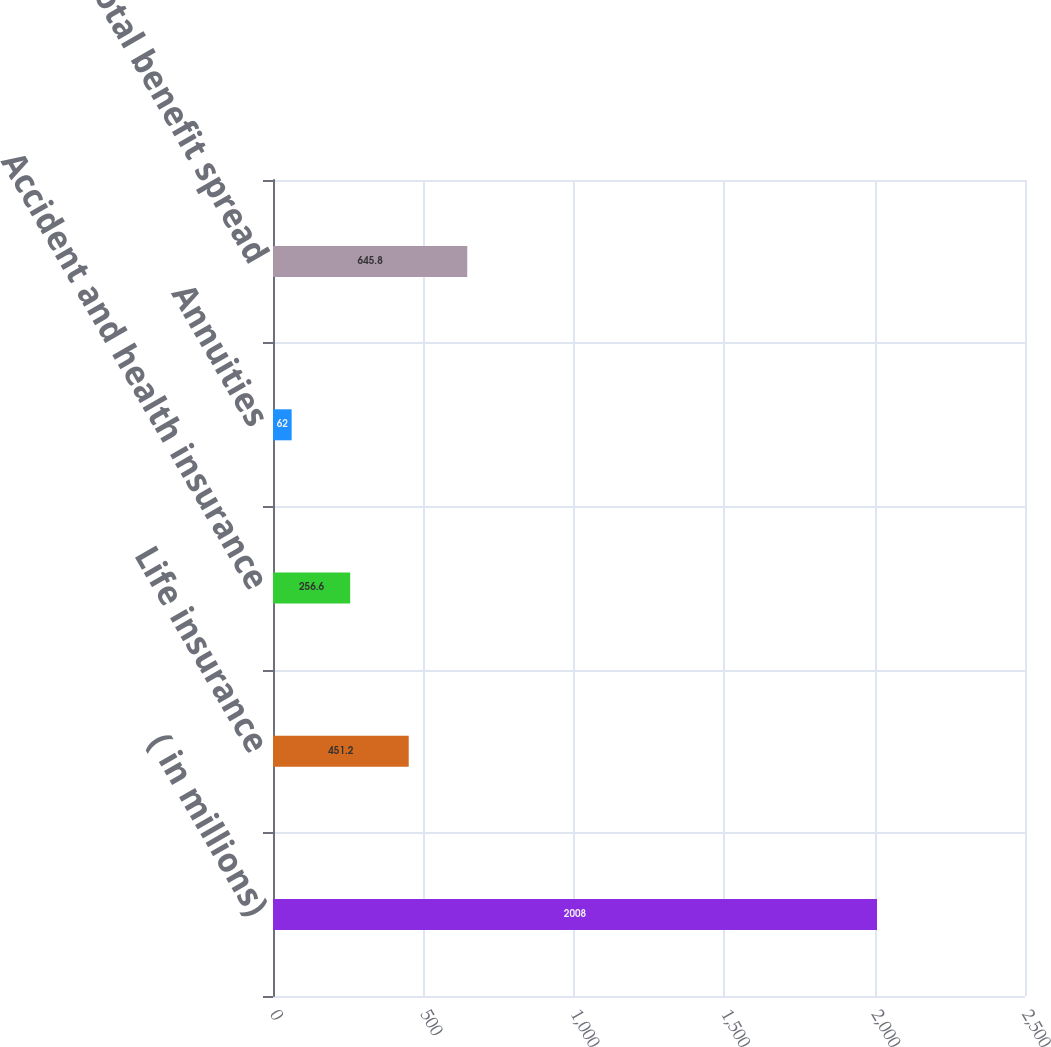Convert chart to OTSL. <chart><loc_0><loc_0><loc_500><loc_500><bar_chart><fcel>( in millions)<fcel>Life insurance<fcel>Accident and health insurance<fcel>Annuities<fcel>Total benefit spread<nl><fcel>2008<fcel>451.2<fcel>256.6<fcel>62<fcel>645.8<nl></chart> 